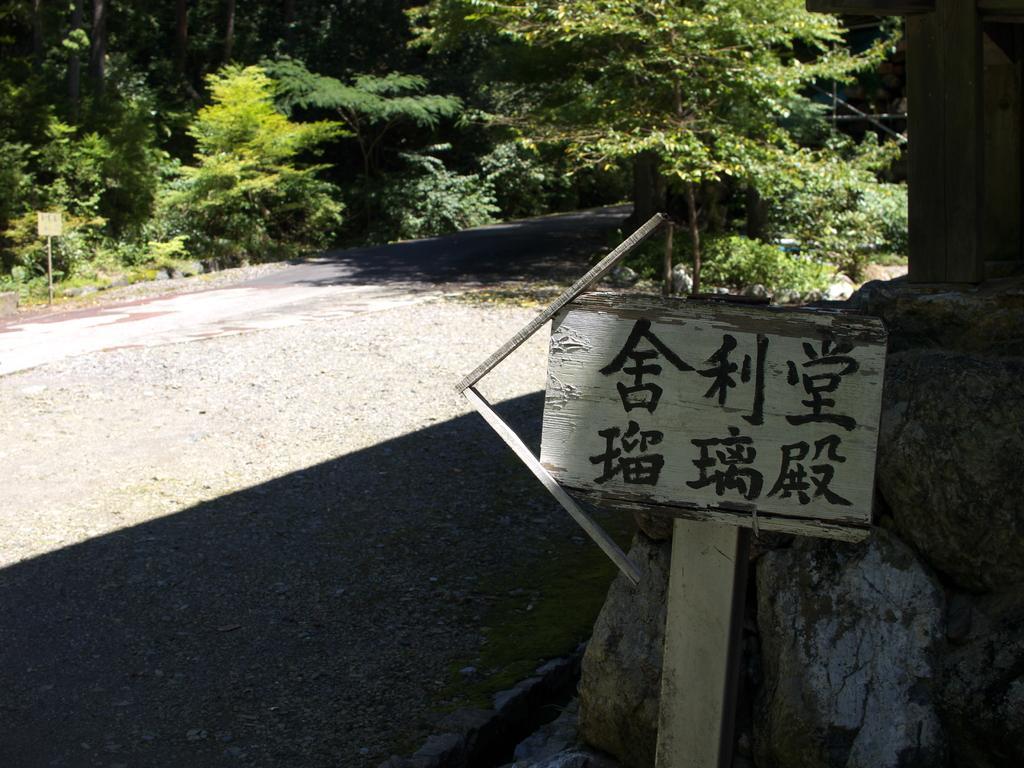In one or two sentences, can you explain what this image depicts? In this image we can see a signboard with some text on it. We can also see the rocks, plants, a group of trees and a board. 